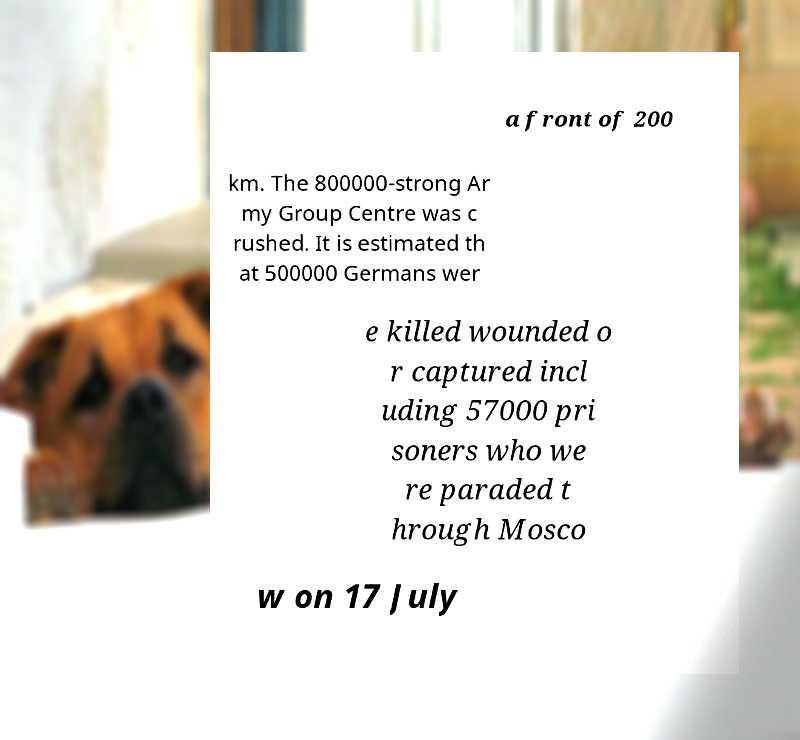What messages or text are displayed in this image? I need them in a readable, typed format. a front of 200 km. The 800000-strong Ar my Group Centre was c rushed. It is estimated th at 500000 Germans wer e killed wounded o r captured incl uding 57000 pri soners who we re paraded t hrough Mosco w on 17 July 